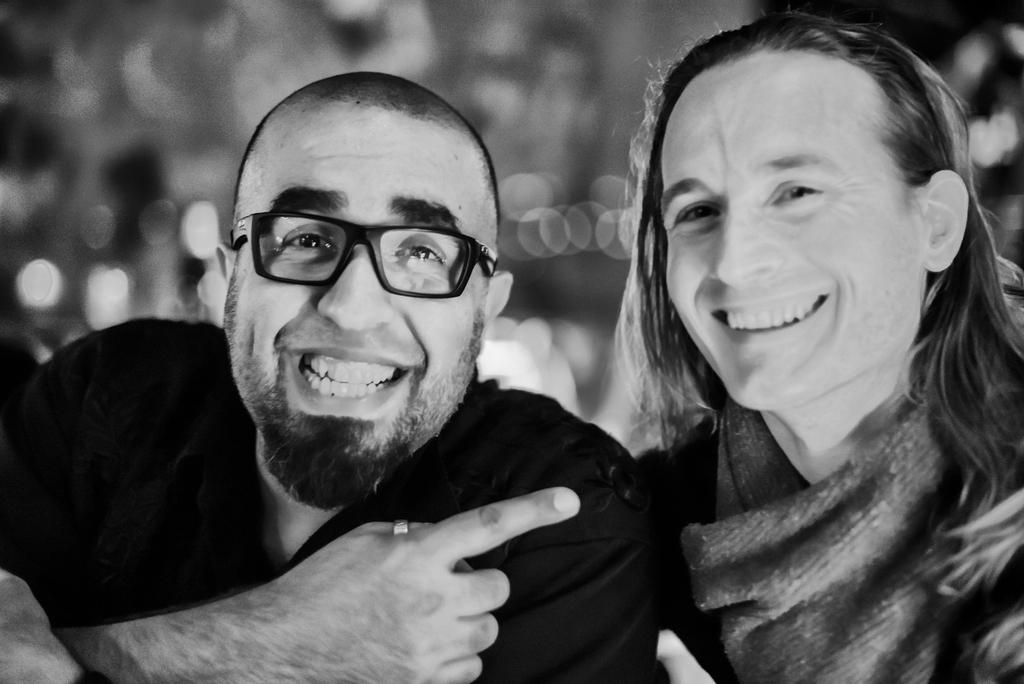How many people are wearing dresses in the image? There are two people with dresses in the image. What accessory is worn by one of the people in the image? One person is wearing specs in the image. Can you describe the background of the image? The background of the image is blurred. What color scheme is used in the image? The image is black and white. What type of soda can be seen in the can in the image? There is no can or soda present in the image. How does the heart shape appear in the image? There is no heart shape present in the image. 